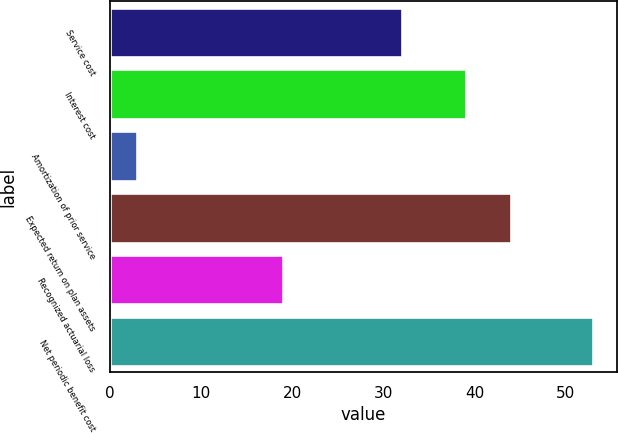<chart> <loc_0><loc_0><loc_500><loc_500><bar_chart><fcel>Service cost<fcel>Interest cost<fcel>Amortization of prior service<fcel>Expected return on plan assets<fcel>Recognized actuarial loss<fcel>Net periodic benefit cost<nl><fcel>32<fcel>39<fcel>3<fcel>44<fcel>19<fcel>53<nl></chart> 